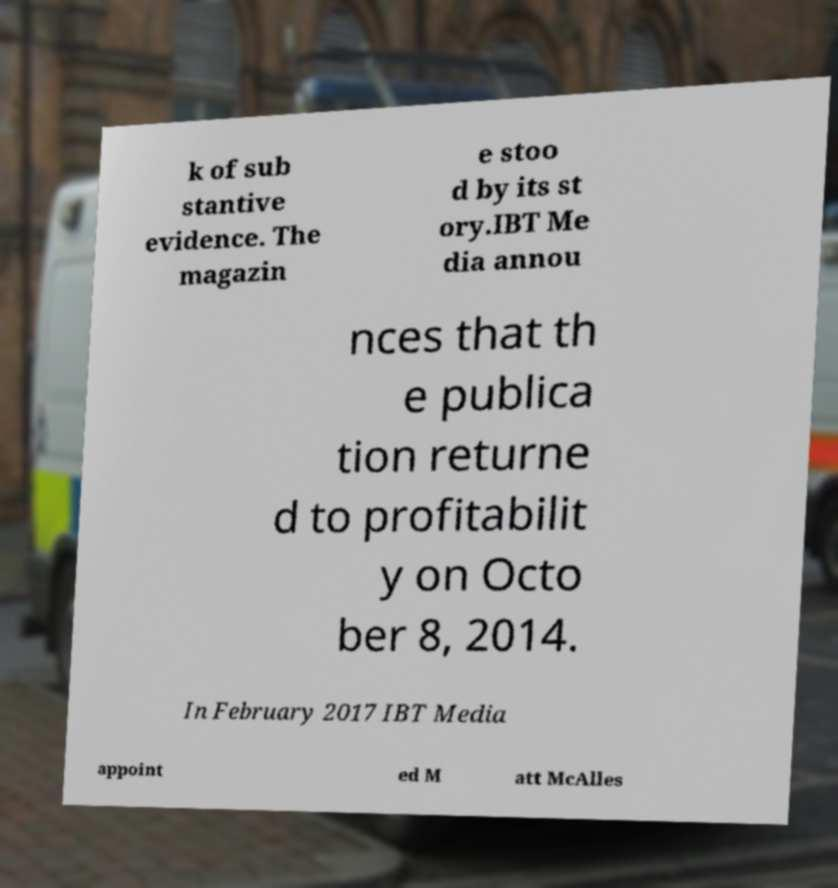Could you extract and type out the text from this image? k of sub stantive evidence. The magazin e stoo d by its st ory.IBT Me dia annou nces that th e publica tion returne d to profitabilit y on Octo ber 8, 2014. In February 2017 IBT Media appoint ed M att McAlles 